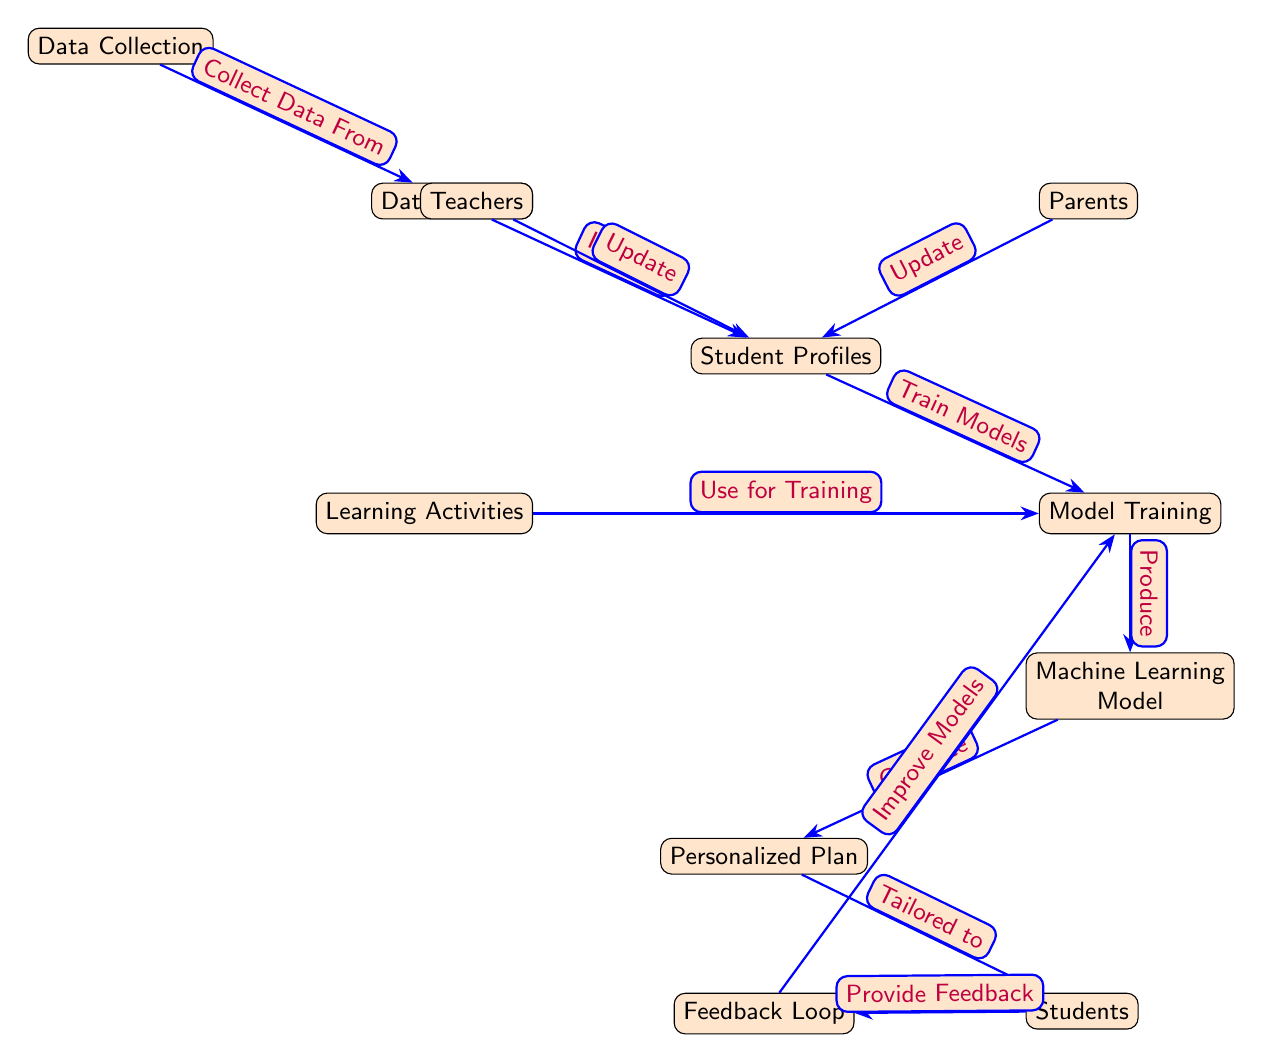What is the input to the student profiles node? The input to the student profiles node comes from the data sources node, as shown by the directed arrow between these two nodes labeled "Input to."
Answer: Data Sources How many edges are in this diagram? By counting the arrows between the nodes, there are a total of eight edges connecting the various components of the diagram.
Answer: Eight What do teachers do in this diagram? According to the diagram, teachers update the student profiles, which is indicated by the arrow connecting teachers to student profiles with the label "Update."
Answer: Update What is the output of the model training node? The output of the model training node is the machine learning model, which is represented as the next node interconnected by the directed arrow labeled "Produce."
Answer: Machine Learning Model What is the role of the feedback loop in this diagram? The feedback loop's role is to provide feedback from students back to the model training node in order to improve the models, demonstrated by the directed arrows connecting these nodes labeled "Provide Feedback" and "Improve Models."
Answer: Improve Models What initiates the personalized plan generation? The personalized plan is generated as an output from the machine learning model, indicated by the directed arrow leading from machine learning model to personalized plan, annotated with "Generate."
Answer: Generate How do parents contribute to the system? Parents contribute by updating the student profiles, shown by the directed arrow from the parents node to the student profiles node labeled "Update."
Answer: Update What type of learning activities are involved in the model training? The learning activities are used for training, illustrated by the connection between learning activities and model training with the label "Use for Training."
Answer: Use for Training What focuses on adapting education to the individual? The personalized plan focuses on tailoring educational content to the individual student based on data processed through the machine learning model, as indicated by the arrow from the personalized plan to the students node labeled "Tailored to."
Answer: Tailored to 